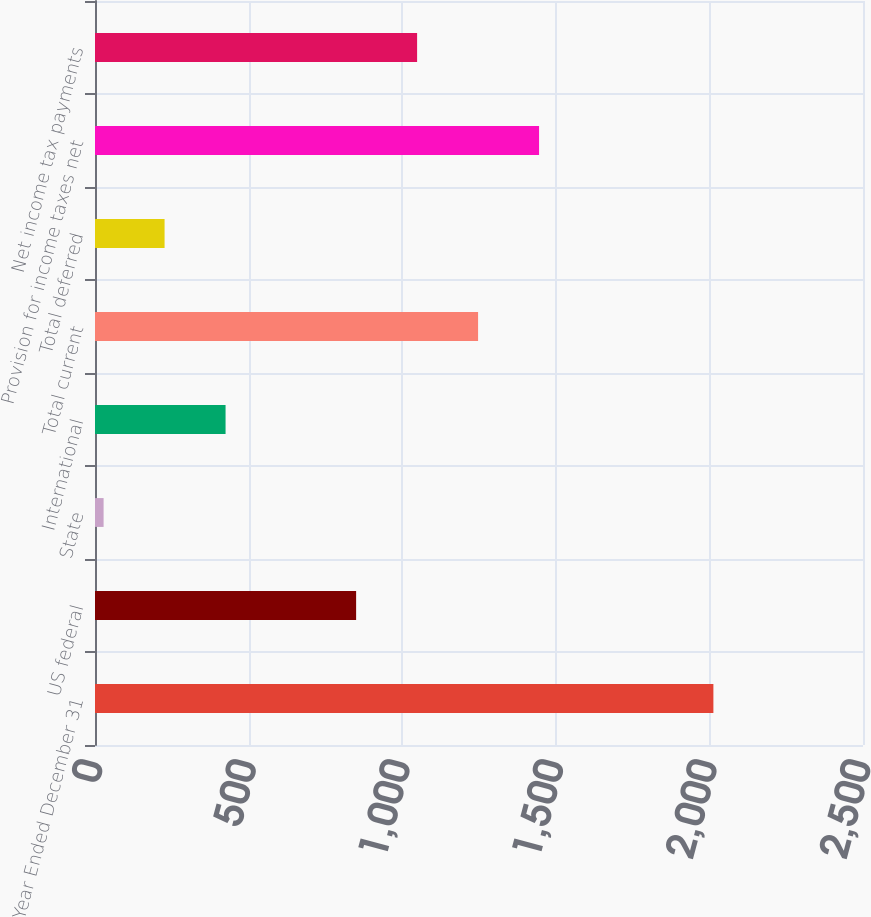Convert chart to OTSL. <chart><loc_0><loc_0><loc_500><loc_500><bar_chart><fcel>Year Ended December 31<fcel>US federal<fcel>State<fcel>International<fcel>Total current<fcel>Total deferred<fcel>Provision for income taxes net<fcel>Net income tax payments<nl><fcel>2013<fcel>850<fcel>28<fcel>425<fcel>1247<fcel>226.5<fcel>1445.5<fcel>1048.5<nl></chart> 